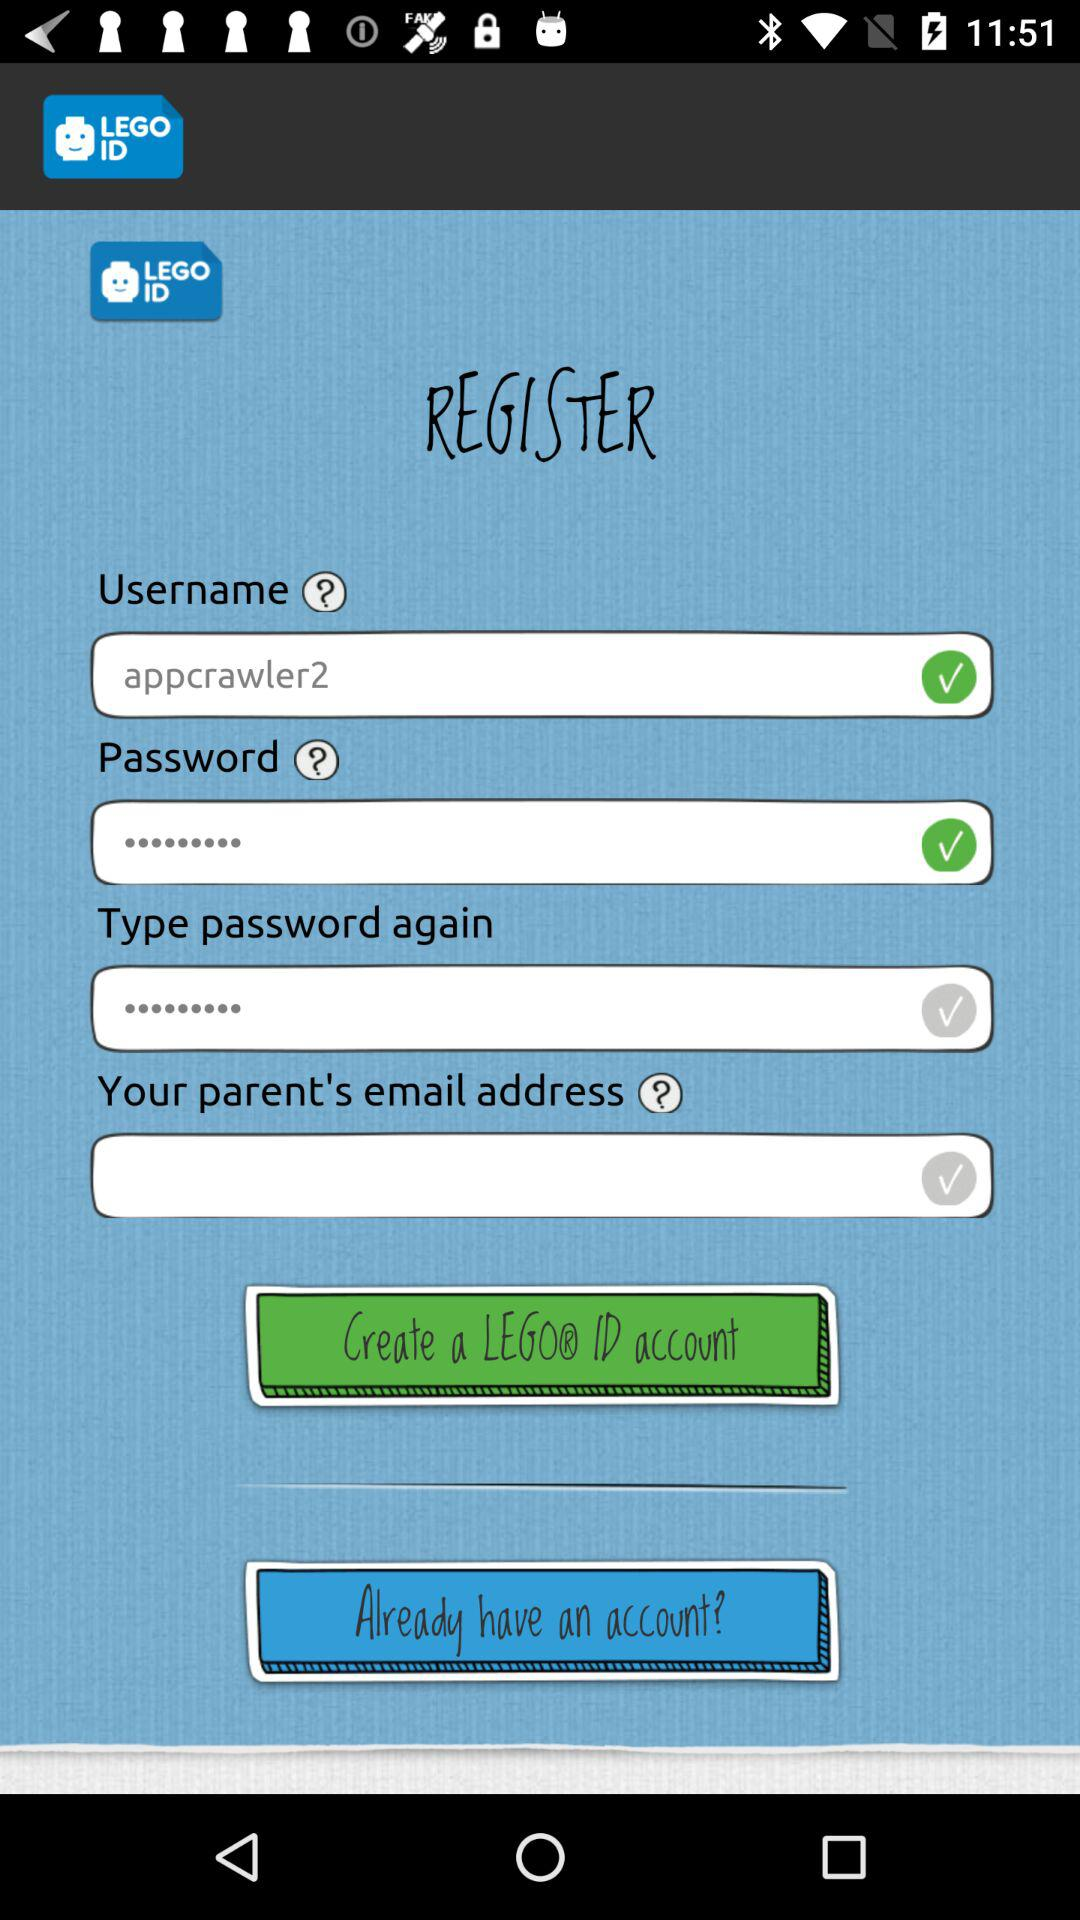What is the application name? The application name is "LEGO ID". 